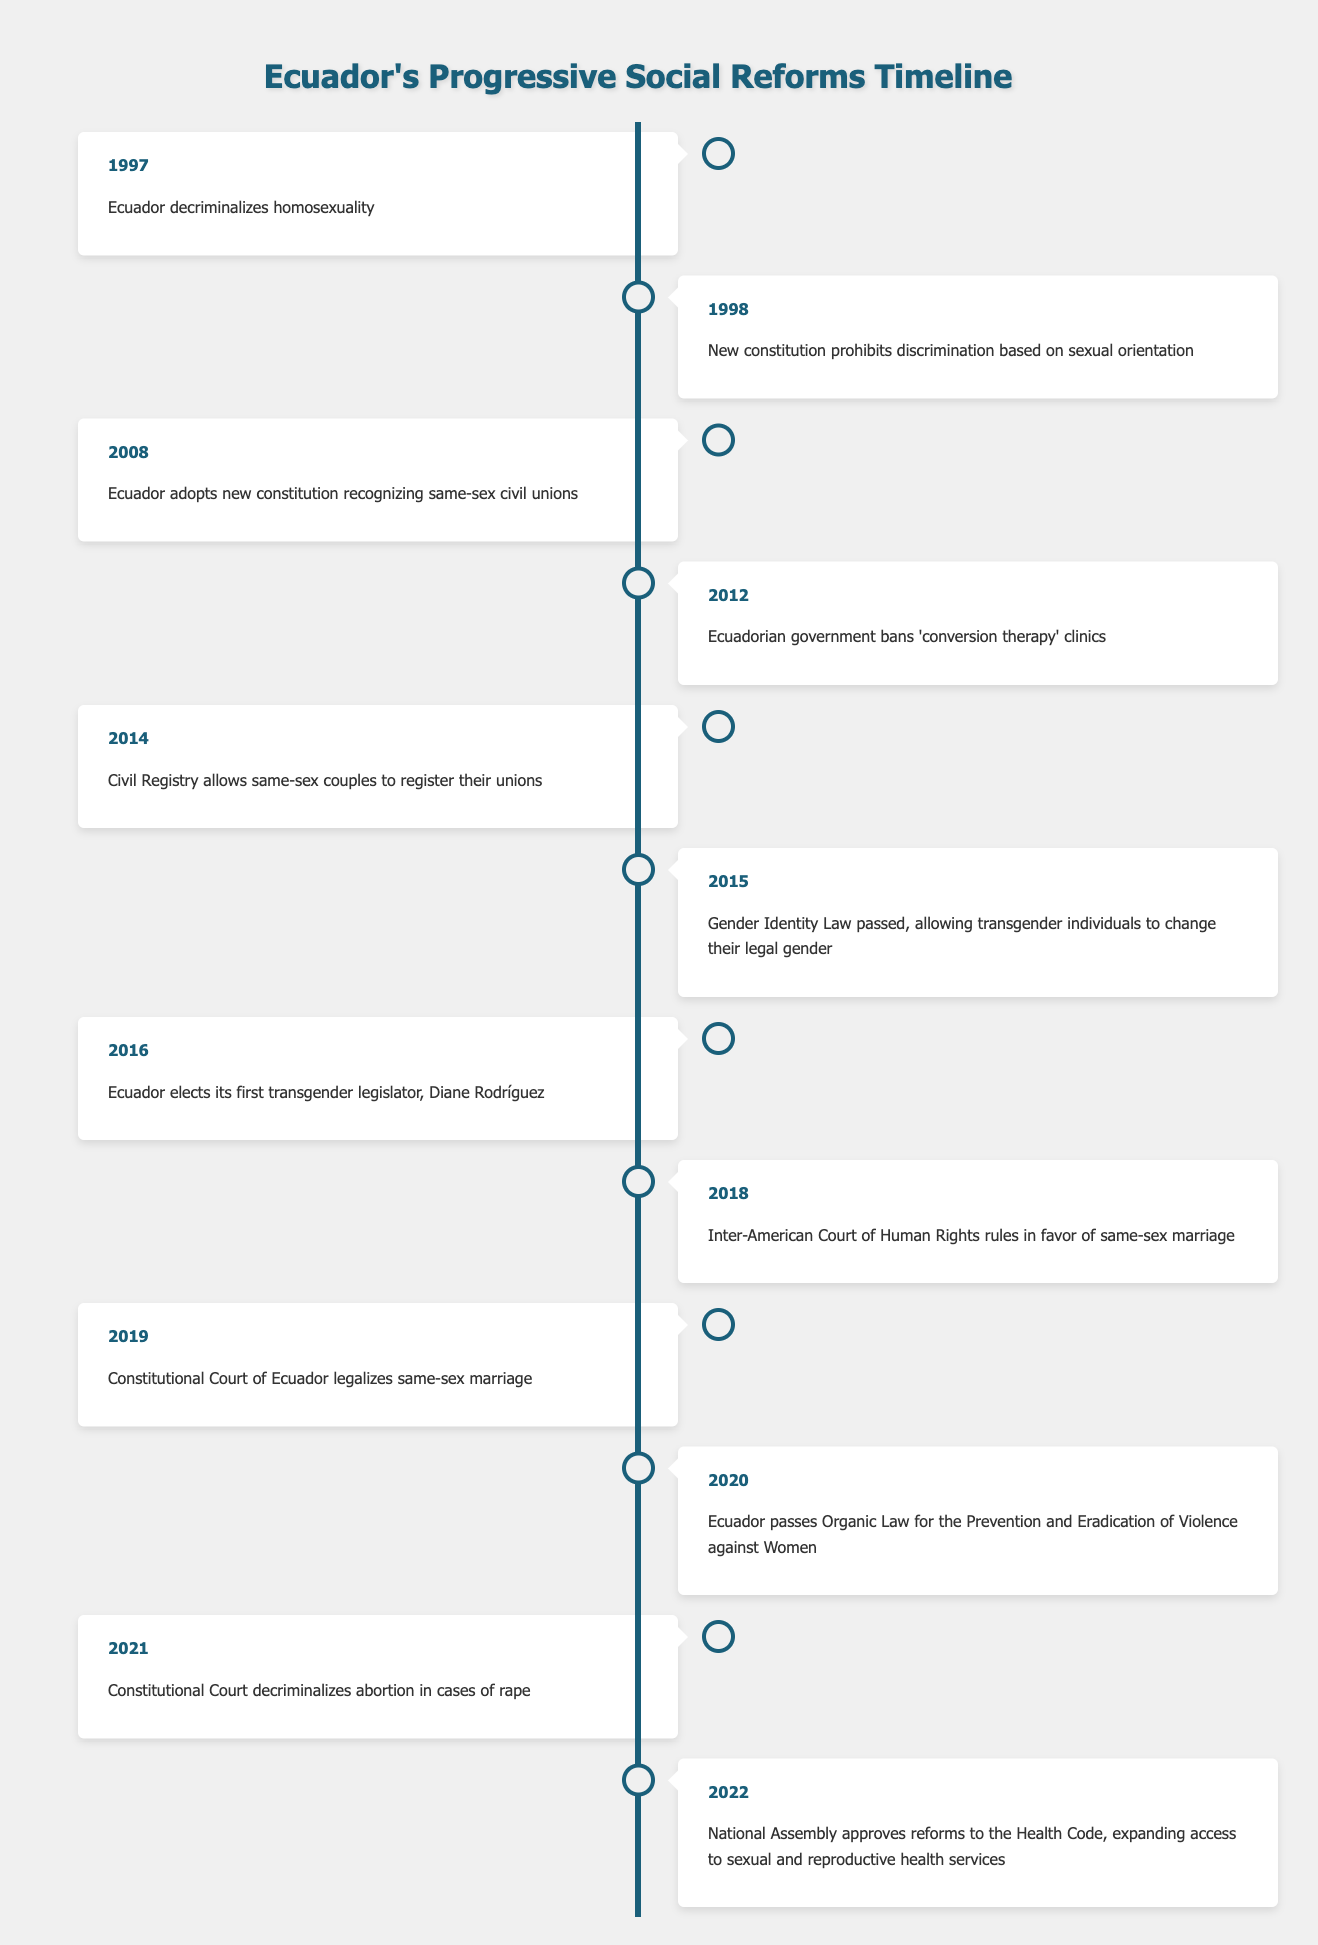What significant event occurred in 1997 in Ecuador? According to the table, the significant event in 1997 is that Ecuador decriminalized homosexuality. This marks a crucial step in LGBTQ+ rights in the country.
Answer: Ecuador decriminalized homosexuality How many years passed between the decriminalization of homosexuality and the legalization of same-sex marriage? The decriminalization of homosexuality took place in 1997, and same-sex marriage was legalized in 2019. The number of years between these two events is 2019 - 1997 = 22 years.
Answer: 22 years Did Ecuador ban 'conversion therapy' clinics before or after the new constitution recognized same-sex civil unions? The new constitution recognizing same-sex civil unions was adopted in 2008, while the ban on 'conversion therapy' clinics occurred in 2012. Since 2012 is after 2008, the ban occurred after the recognition of civil unions.
Answer: After What was the first milestone in Ecuador's progressive social reforms related to women's rights? The Organic Law for the Prevention and Eradication of Violence against Women was passed in 2020, making it the first milestone specifically addressing women's rights in the table.
Answer: 2020 How many events in the table are specifically related to LGBTQ+ rights? There are 8 events related to LGBTQ+ rights in total: 1997 (decriminalization), 1998 (constitution), 2008 (civil unions), 2012 (conversion therapy ban), 2014 (registration), 2015 (gender identity law), 2016 (trans legislator), 2019 (same-sex marriage).
Answer: 8 events What are the years when significant reforms for sexual and reproductive health were made in Ecuador? The significant reforms related to sexual and reproductive health occurred in 2021 (decriminalization of abortion in rape cases) and in 2022 (reforms to the Health Code). Therefore, the years are 2021 and 2022.
Answer: 2021 and 2022 Is there any event that occurred in the same year related to both LGBTQ+ rights and women's rights? Yes, in 2020, Ecuador passed the Organic Law for the Prevention and Eradication of Violence against Women, and this year is not associated with any LGBTQ+ events. However, 2021 saw the decriminalization of abortion related to women's rights. So there are no overlapping events in the same year for both categories.
Answer: No Which law allows transgender individuals to change their legal gender, and in what year was it passed? The Gender Identity Law, allowing transgender individuals to change their legal gender, was passed in 2015.
Answer: Gender Identity Law in 2015 